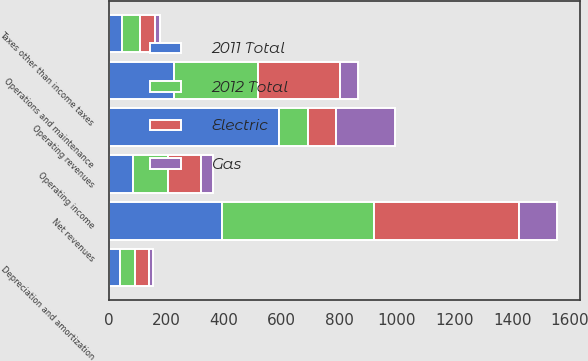Convert chart. <chart><loc_0><loc_0><loc_500><loc_500><stacked_bar_chart><ecel><fcel>Operating revenues<fcel>Net revenues<fcel>Operations and maintenance<fcel>Depreciation and amortization<fcel>Taxes other than income taxes<fcel>Operating income<nl><fcel>2011 Total<fcel>592<fcel>394<fcel>227<fcel>38<fcel>46<fcel>83<nl><fcel>Gas<fcel>203<fcel>134<fcel>64<fcel>15<fcel>15<fcel>40<nl><fcel>2012 Total<fcel>98.5<fcel>528<fcel>291<fcel>53<fcel>61<fcel>123<nl><fcel>Electric<fcel>98.5<fcel>501<fcel>284<fcel>48<fcel>55<fcel>114<nl></chart> 